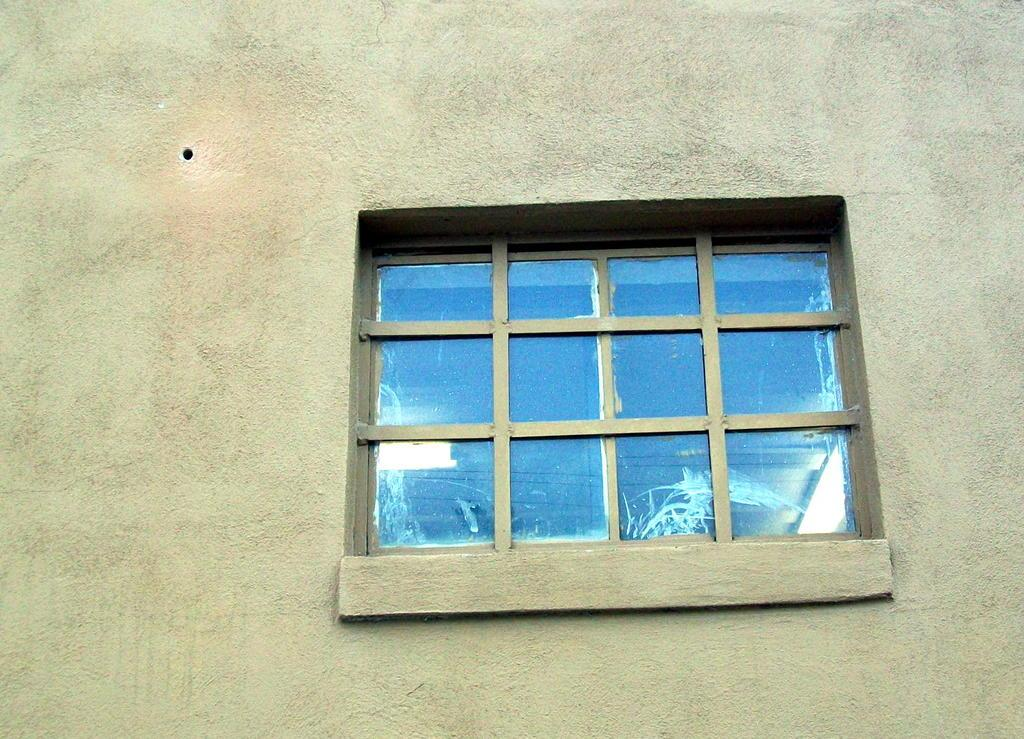What can be seen in the image that provides a view of the outdoors? There is a window in the image. Where is the window located in the image? The window is on a wall. What type of minister is present at the dinner in the image? There is no minister or dinner present in the image; it only features a window on a wall. 